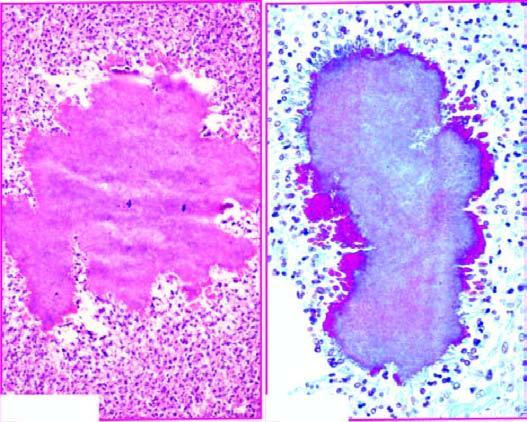does the peripheral zone show hyaline filaments highlighted by masson 's trichrome stain right photomicrograph?
Answer the question using a single word or phrase. No 